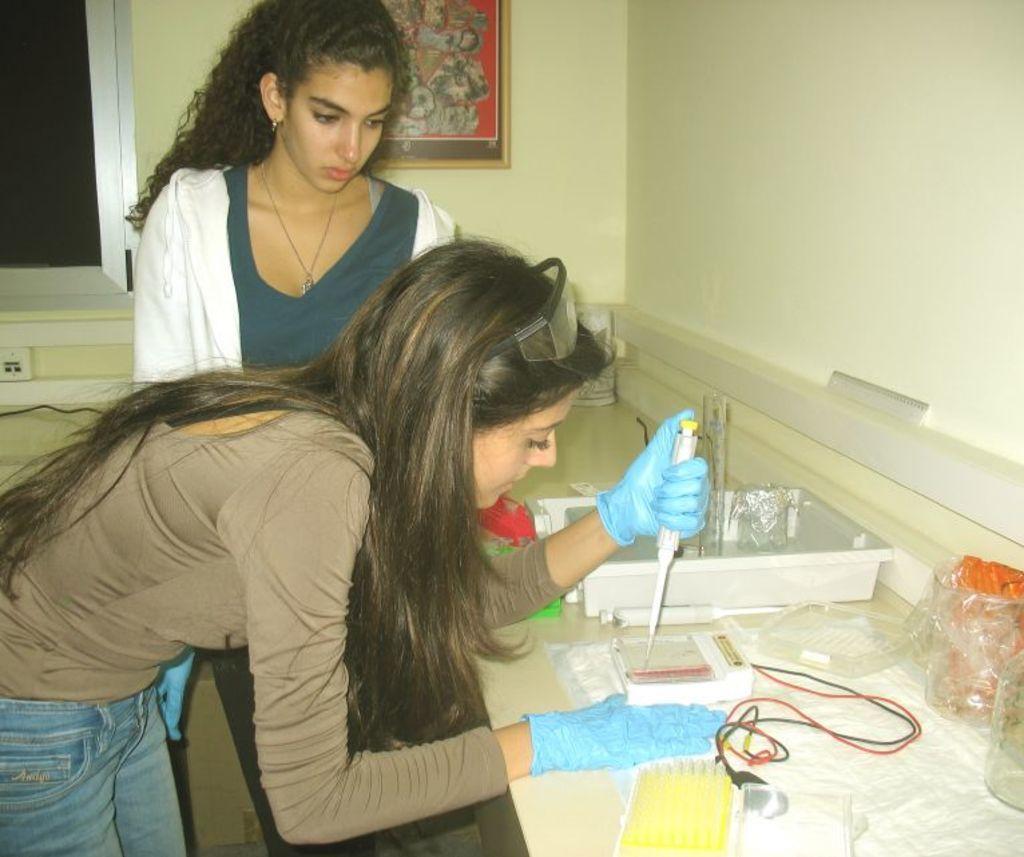How would you summarize this image in a sentence or two? To the left side of the image there is a lady with brown t-shirt is bending and she is having blue gloves to her hands. And she is holding an object in one hand. In front of her there is a table with white box, cover, jars and few other items on it. Behind her there is a lady with white jacket is standing. To the left top corner of the image there is a window. And behind the lady there is a wall with the frame. 